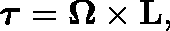Convert formula to latex. <formula><loc_0><loc_0><loc_500><loc_500>{ \tau } = \Omega \times L ,</formula> 